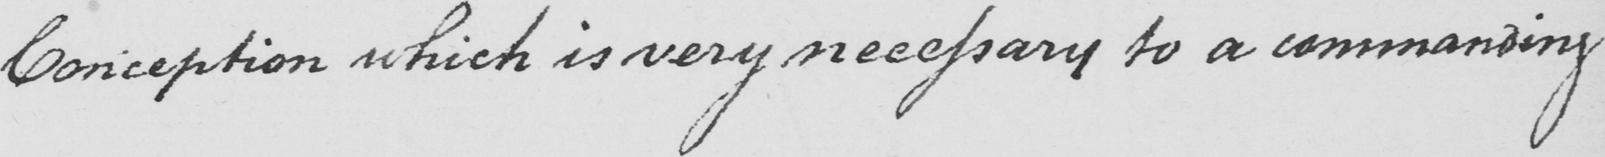Please transcribe the handwritten text in this image. Conception which is very necessary to a commanding 